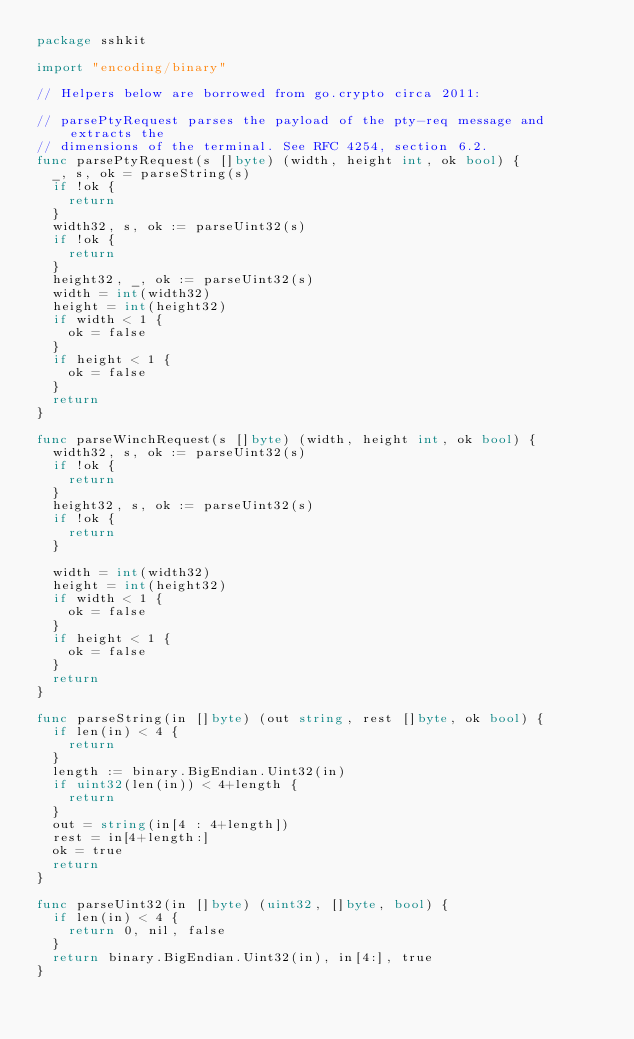Convert code to text. <code><loc_0><loc_0><loc_500><loc_500><_Go_>package sshkit

import "encoding/binary"

// Helpers below are borrowed from go.crypto circa 2011:

// parsePtyRequest parses the payload of the pty-req message and extracts the
// dimensions of the terminal. See RFC 4254, section 6.2.
func parsePtyRequest(s []byte) (width, height int, ok bool) {
	_, s, ok = parseString(s)
	if !ok {
		return
	}
	width32, s, ok := parseUint32(s)
	if !ok {
		return
	}
	height32, _, ok := parseUint32(s)
	width = int(width32)
	height = int(height32)
	if width < 1 {
		ok = false
	}
	if height < 1 {
		ok = false
	}
	return
}

func parseWinchRequest(s []byte) (width, height int, ok bool) {
	width32, s, ok := parseUint32(s)
	if !ok {
		return
	}
	height32, s, ok := parseUint32(s)
	if !ok {
		return
	}

	width = int(width32)
	height = int(height32)
	if width < 1 {
		ok = false
	}
	if height < 1 {
		ok = false
	}
	return
}

func parseString(in []byte) (out string, rest []byte, ok bool) {
	if len(in) < 4 {
		return
	}
	length := binary.BigEndian.Uint32(in)
	if uint32(len(in)) < 4+length {
		return
	}
	out = string(in[4 : 4+length])
	rest = in[4+length:]
	ok = true
	return
}

func parseUint32(in []byte) (uint32, []byte, bool) {
	if len(in) < 4 {
		return 0, nil, false
	}
	return binary.BigEndian.Uint32(in), in[4:], true
}
</code> 